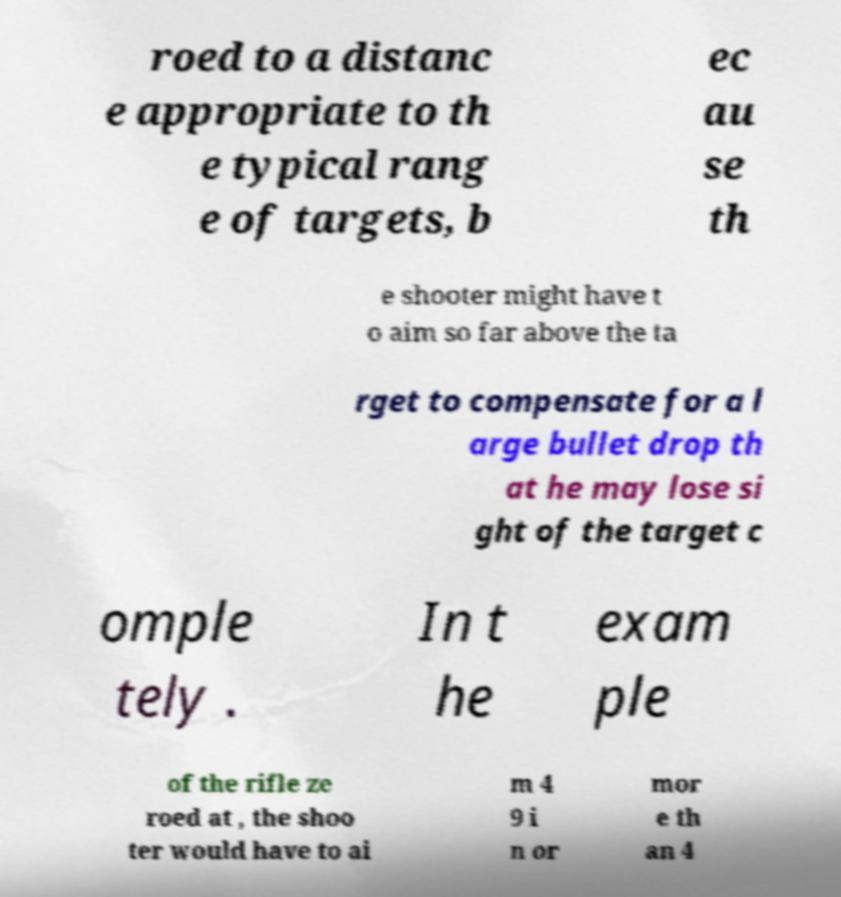Can you accurately transcribe the text from the provided image for me? roed to a distanc e appropriate to th e typical rang e of targets, b ec au se th e shooter might have t o aim so far above the ta rget to compensate for a l arge bullet drop th at he may lose si ght of the target c omple tely . In t he exam ple of the rifle ze roed at , the shoo ter would have to ai m 4 9 i n or mor e th an 4 